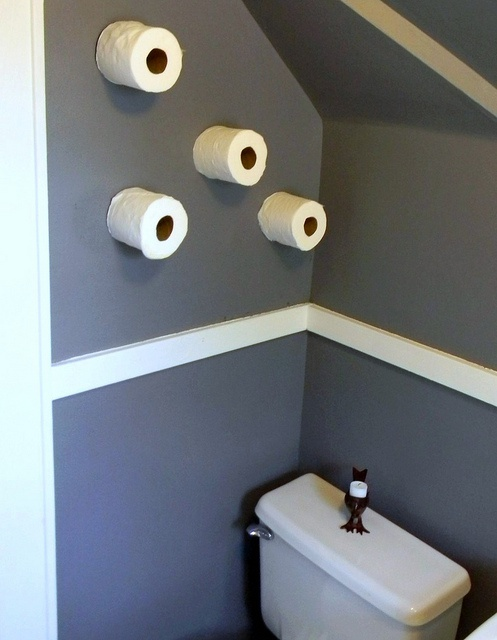Describe the objects in this image and their specific colors. I can see a toilet in ivory, darkgray, and gray tones in this image. 